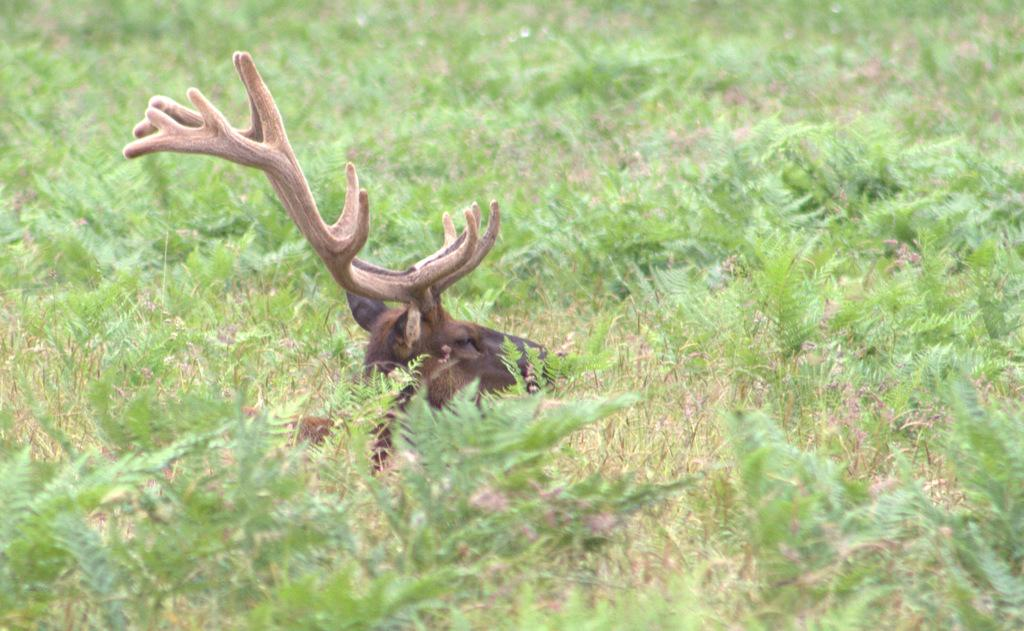What type of living organisms can be seen in the image? Plants can be seen in the image. What other type of living organism is present in the image? There is an animal in the middle of the image. How many elbows can be seen on the animal in the image? There are no elbows present on the animal in the image, as animals do not have elbows. 